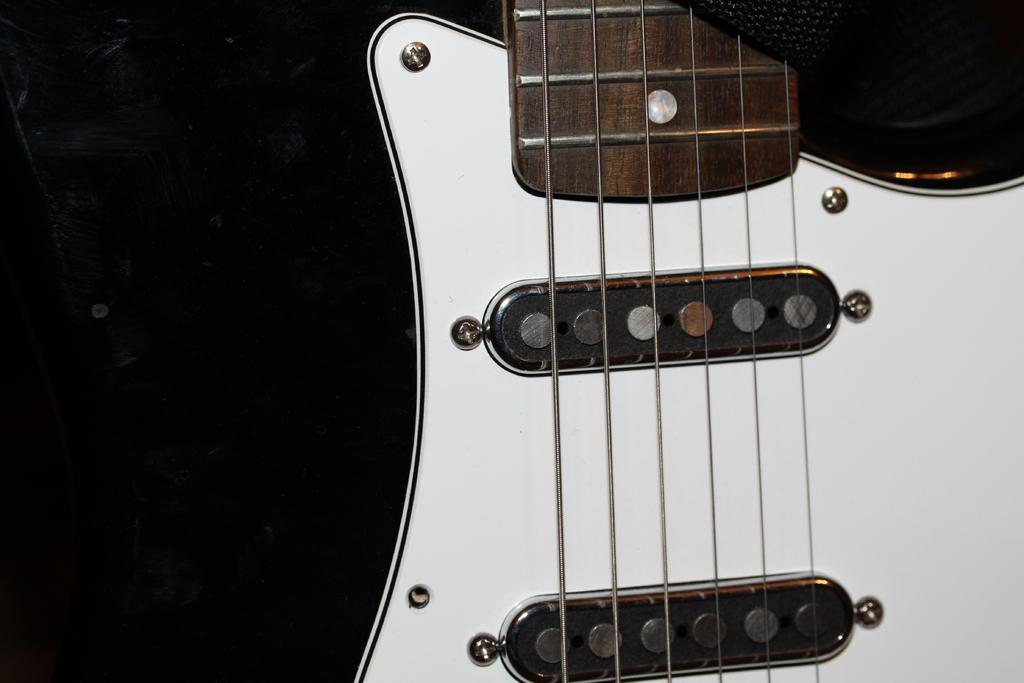What type of musical instrument is depicted in the image? The object is a guitar. What type of skin can be seen on the wall in the image? There is no wall or skin present in the image; it features a guitar. What type of sheet is covering the guitar in the image? There is: There is no sheet covering the guitar in the image; it is visible in its entirety. 